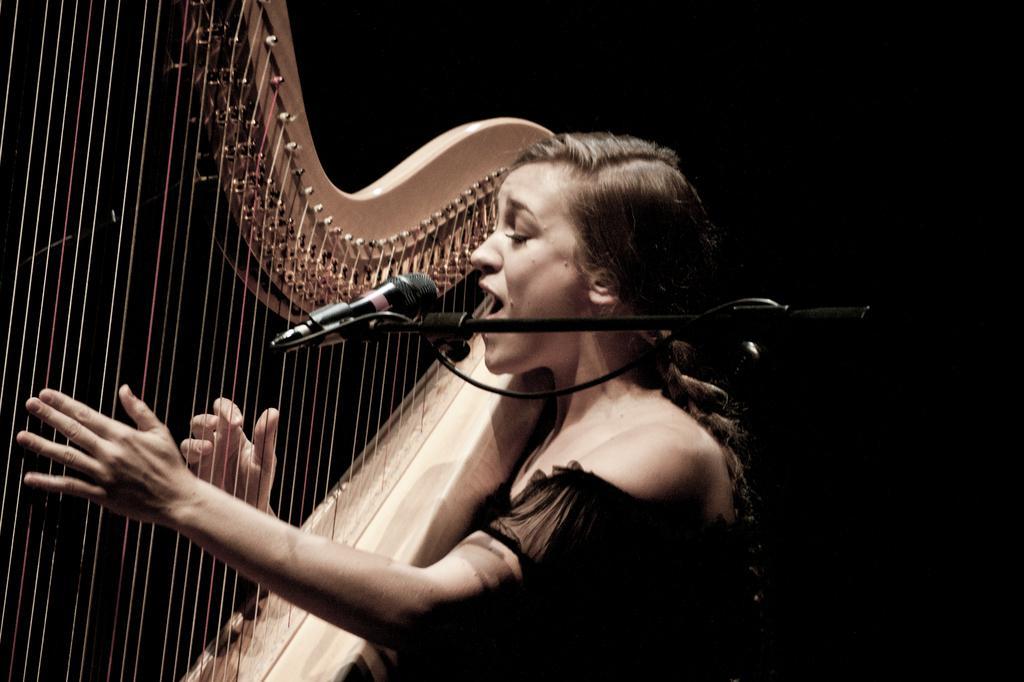Can you describe this image briefly? In this image we can see a woman singing and playing a musical instrument and there is a mic. 